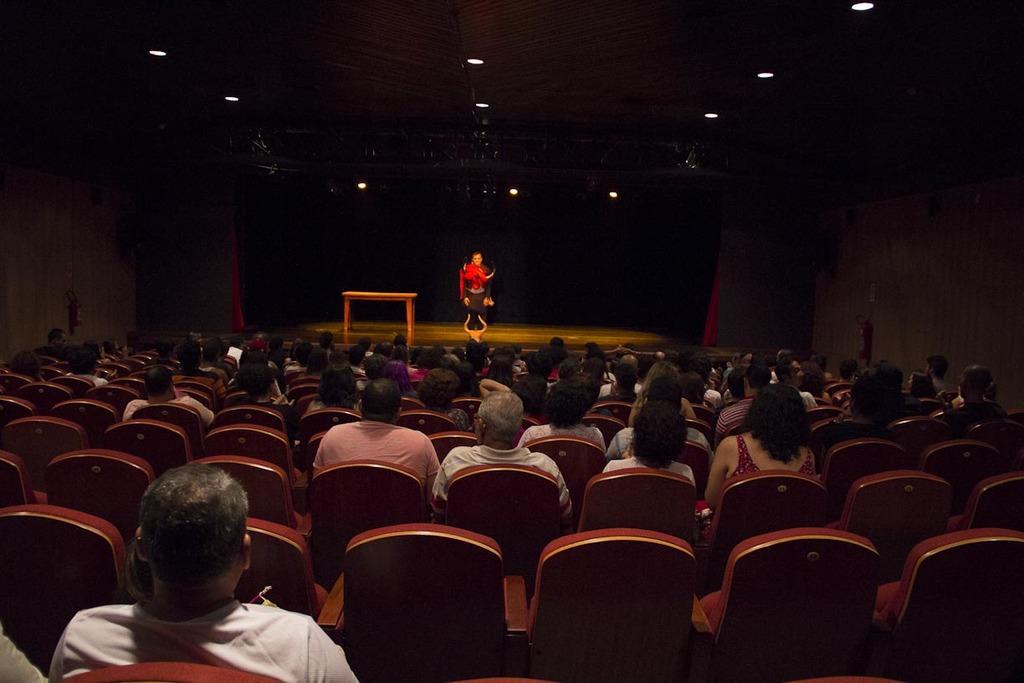Please provide a concise description of this image. In this image there is a person on the stage, there are a few people sitting in the chairs in front of the stage, there are some lights to the roof and a table on the stage. 